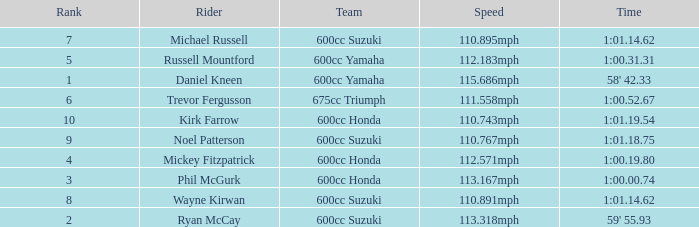What time has phil mcgurk as the rider? 1:00.00.74. 